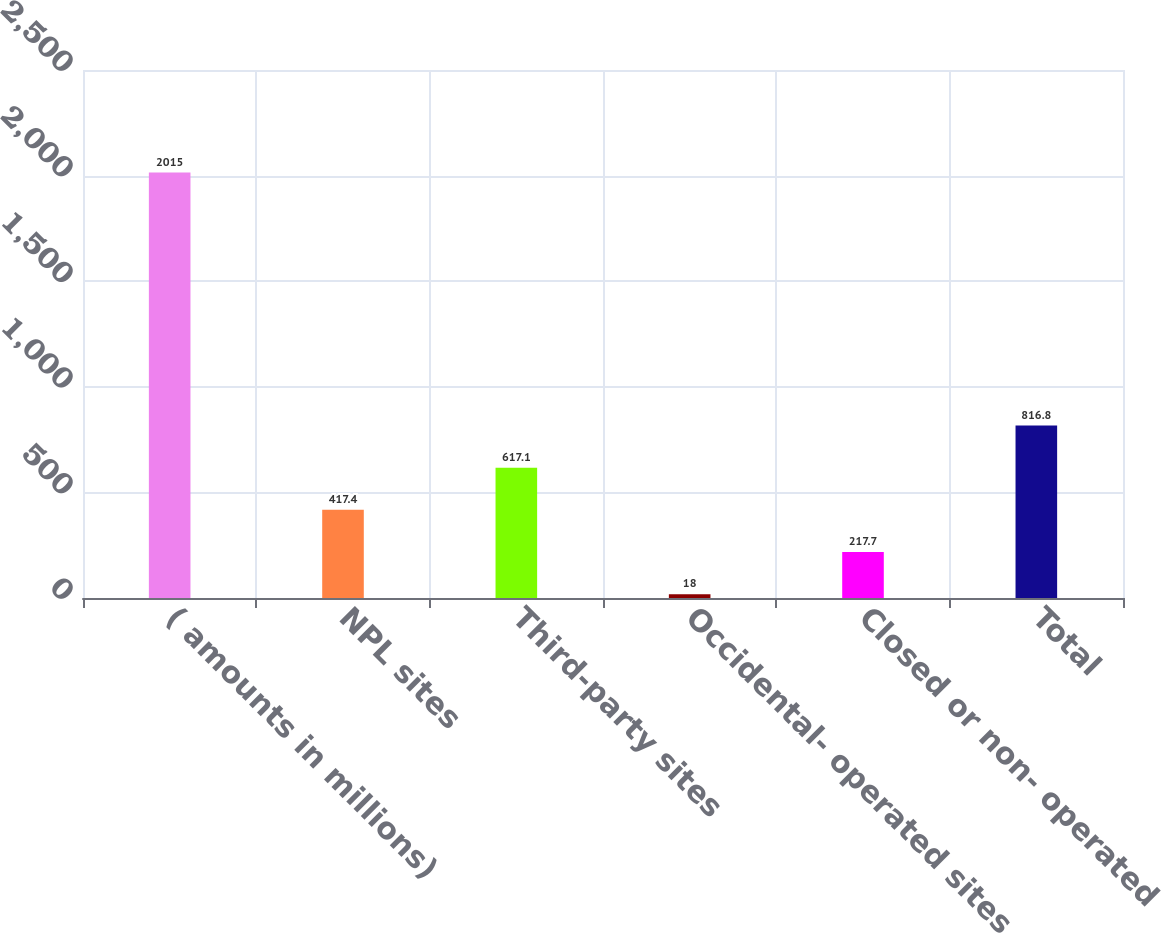Convert chart. <chart><loc_0><loc_0><loc_500><loc_500><bar_chart><fcel>( amounts in millions)<fcel>NPL sites<fcel>Third-party sites<fcel>Occidental- operated sites<fcel>Closed or non- operated<fcel>Total<nl><fcel>2015<fcel>417.4<fcel>617.1<fcel>18<fcel>217.7<fcel>816.8<nl></chart> 